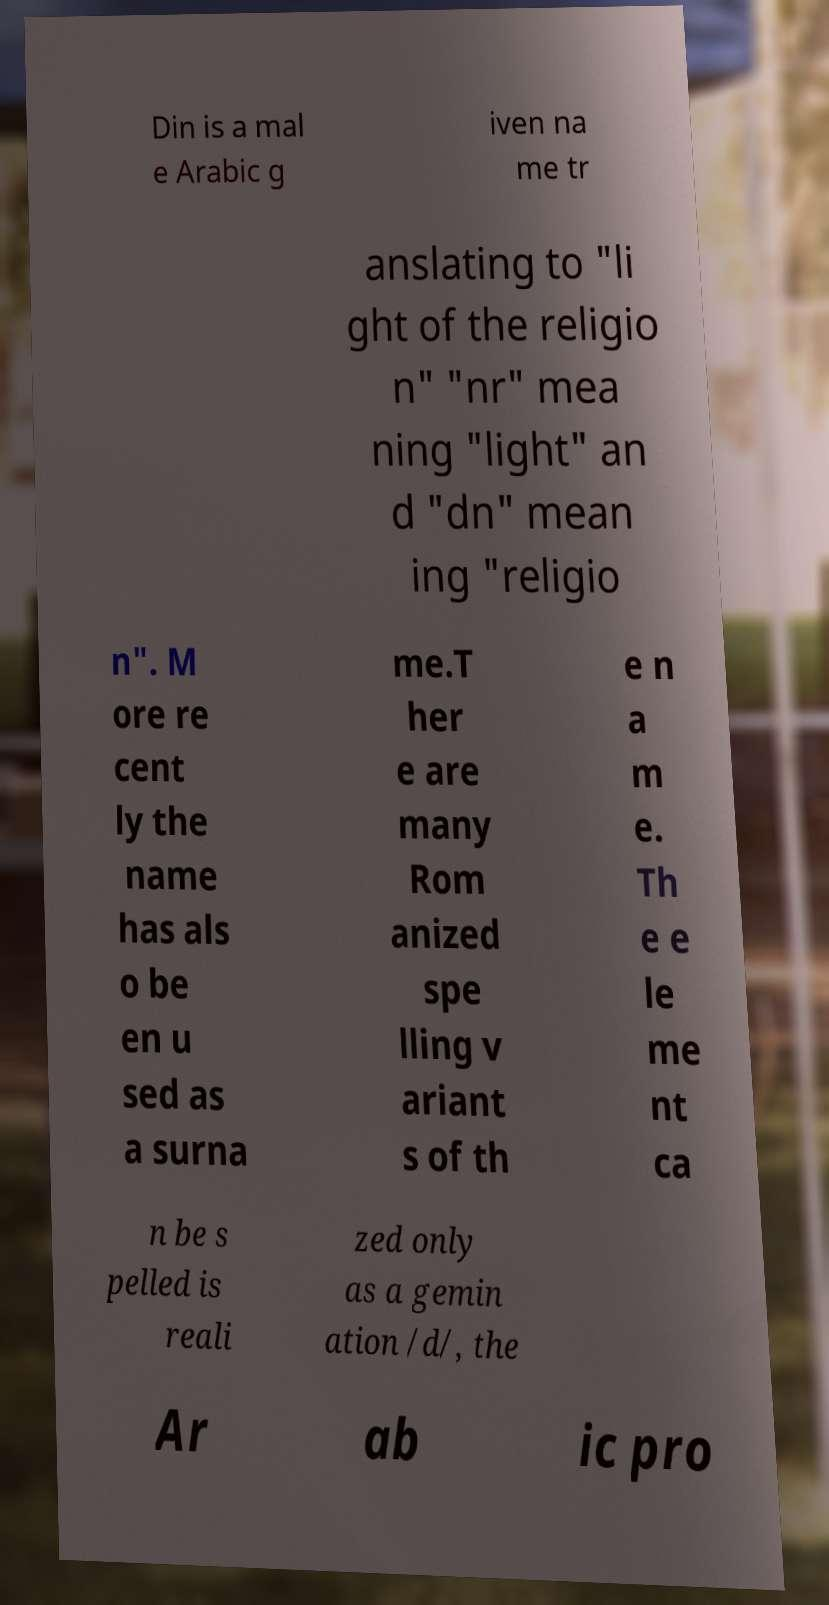What messages or text are displayed in this image? I need them in a readable, typed format. Din is a mal e Arabic g iven na me tr anslating to "li ght of the religio n" "nr" mea ning "light" an d "dn" mean ing "religio n". M ore re cent ly the name has als o be en u sed as a surna me.T her e are many Rom anized spe lling v ariant s of th e n a m e. Th e e le me nt ca n be s pelled is reali zed only as a gemin ation /d/, the Ar ab ic pro 